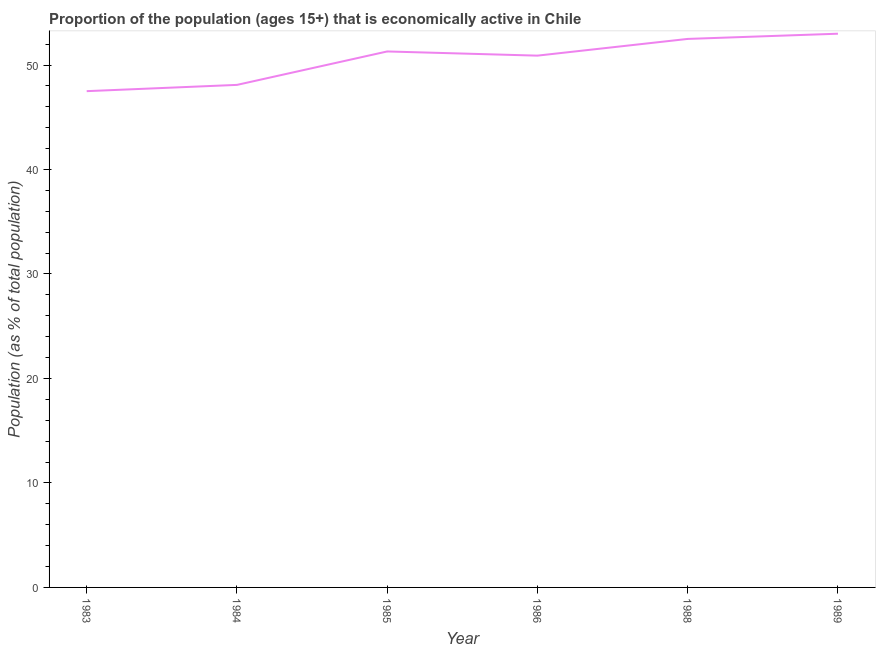What is the percentage of economically active population in 1986?
Offer a terse response. 50.9. Across all years, what is the maximum percentage of economically active population?
Your answer should be compact. 53. Across all years, what is the minimum percentage of economically active population?
Provide a short and direct response. 47.5. What is the sum of the percentage of economically active population?
Ensure brevity in your answer.  303.3. What is the difference between the percentage of economically active population in 1988 and 1989?
Make the answer very short. -0.5. What is the average percentage of economically active population per year?
Provide a short and direct response. 50.55. What is the median percentage of economically active population?
Give a very brief answer. 51.1. What is the ratio of the percentage of economically active population in 1986 to that in 1988?
Keep it short and to the point. 0.97. Is the difference between the percentage of economically active population in 1985 and 1986 greater than the difference between any two years?
Ensure brevity in your answer.  No. What is the difference between the highest and the second highest percentage of economically active population?
Provide a short and direct response. 0.5. What is the difference between the highest and the lowest percentage of economically active population?
Give a very brief answer. 5.5. How many lines are there?
Give a very brief answer. 1. How many years are there in the graph?
Provide a succinct answer. 6. Are the values on the major ticks of Y-axis written in scientific E-notation?
Provide a succinct answer. No. Does the graph contain any zero values?
Your response must be concise. No. Does the graph contain grids?
Offer a very short reply. No. What is the title of the graph?
Offer a terse response. Proportion of the population (ages 15+) that is economically active in Chile. What is the label or title of the Y-axis?
Offer a very short reply. Population (as % of total population). What is the Population (as % of total population) in 1983?
Provide a short and direct response. 47.5. What is the Population (as % of total population) in 1984?
Make the answer very short. 48.1. What is the Population (as % of total population) in 1985?
Ensure brevity in your answer.  51.3. What is the Population (as % of total population) in 1986?
Your answer should be compact. 50.9. What is the Population (as % of total population) of 1988?
Provide a short and direct response. 52.5. What is the difference between the Population (as % of total population) in 1983 and 1984?
Keep it short and to the point. -0.6. What is the difference between the Population (as % of total population) in 1983 and 1986?
Keep it short and to the point. -3.4. What is the difference between the Population (as % of total population) in 1983 and 1988?
Keep it short and to the point. -5. What is the difference between the Population (as % of total population) in 1984 and 1985?
Your response must be concise. -3.2. What is the difference between the Population (as % of total population) in 1984 and 1988?
Provide a short and direct response. -4.4. What is the difference between the Population (as % of total population) in 1985 and 1986?
Provide a succinct answer. 0.4. What is the difference between the Population (as % of total population) in 1985 and 1988?
Give a very brief answer. -1.2. What is the difference between the Population (as % of total population) in 1985 and 1989?
Your answer should be compact. -1.7. What is the difference between the Population (as % of total population) in 1986 and 1988?
Provide a succinct answer. -1.6. What is the difference between the Population (as % of total population) in 1988 and 1989?
Make the answer very short. -0.5. What is the ratio of the Population (as % of total population) in 1983 to that in 1984?
Your answer should be compact. 0.99. What is the ratio of the Population (as % of total population) in 1983 to that in 1985?
Make the answer very short. 0.93. What is the ratio of the Population (as % of total population) in 1983 to that in 1986?
Provide a short and direct response. 0.93. What is the ratio of the Population (as % of total population) in 1983 to that in 1988?
Provide a short and direct response. 0.91. What is the ratio of the Population (as % of total population) in 1983 to that in 1989?
Provide a short and direct response. 0.9. What is the ratio of the Population (as % of total population) in 1984 to that in 1985?
Ensure brevity in your answer.  0.94. What is the ratio of the Population (as % of total population) in 1984 to that in 1986?
Offer a very short reply. 0.94. What is the ratio of the Population (as % of total population) in 1984 to that in 1988?
Provide a succinct answer. 0.92. What is the ratio of the Population (as % of total population) in 1984 to that in 1989?
Give a very brief answer. 0.91. What is the ratio of the Population (as % of total population) in 1985 to that in 1986?
Your answer should be compact. 1.01. What is the ratio of the Population (as % of total population) in 1985 to that in 1989?
Your answer should be very brief. 0.97. What is the ratio of the Population (as % of total population) in 1988 to that in 1989?
Keep it short and to the point. 0.99. 